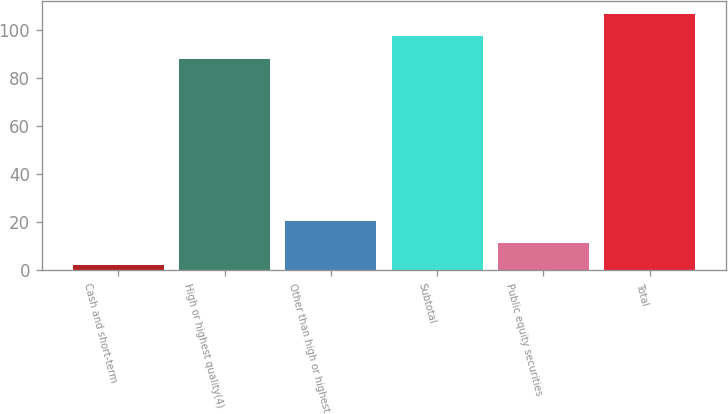Convert chart to OTSL. <chart><loc_0><loc_0><loc_500><loc_500><bar_chart><fcel>Cash and short-term<fcel>High or highest quality(4)<fcel>Other than high or highest<fcel>Subtotal<fcel>Public equity securities<fcel>Total<nl><fcel>2.1<fcel>88.2<fcel>20.68<fcel>97.49<fcel>11.39<fcel>106.78<nl></chart> 